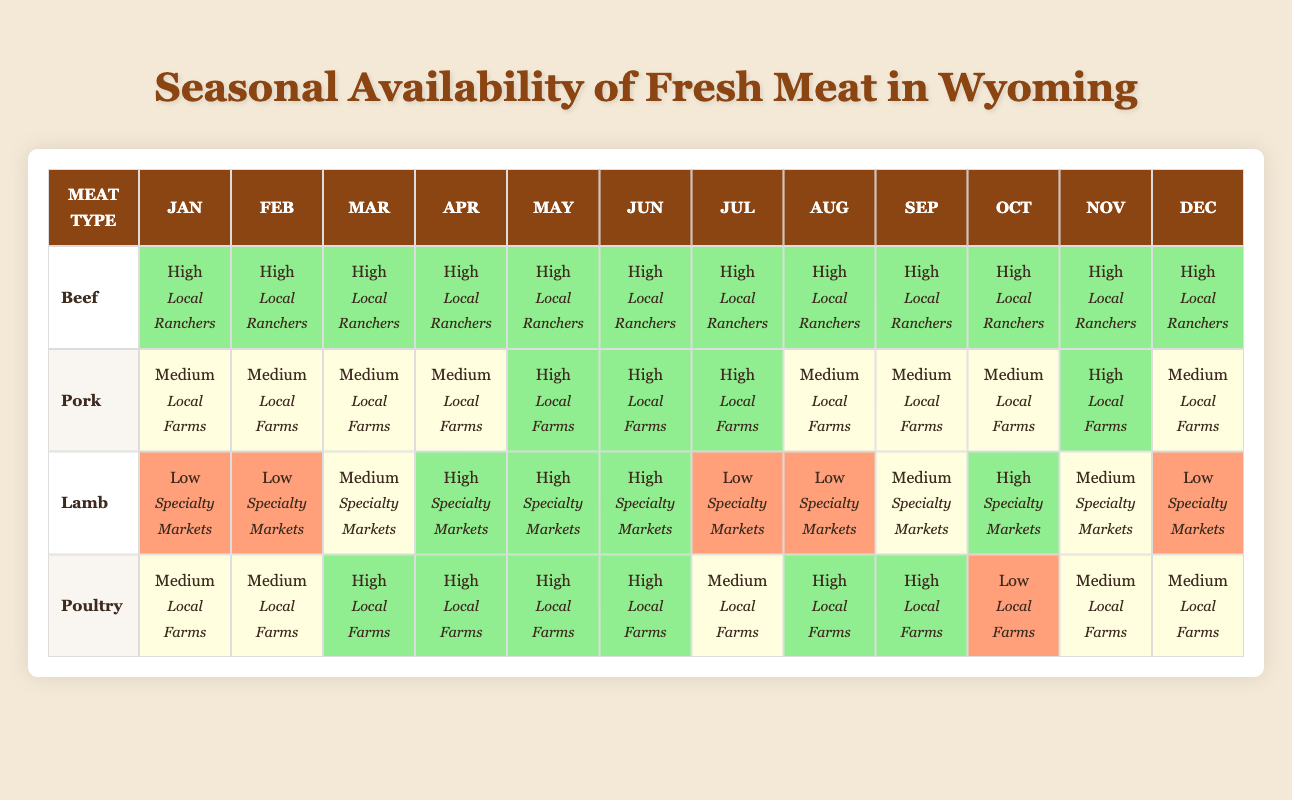What is the availability of beef in January? In January, the table shows "High" availability for beef and specifies the source as "Local Ranchers."
Answer: High During which month does lamb have the highest availability? From the table, lamb shows "High" availability in April, May, and October. The month with the highest availability is therefore April and May.
Answer: April and May Is pork available all year round? The table indicates that pork has "Medium" availability in January, February, March, April, July, August, September, October, December; and "High" availability in May, June, and November. Therefore, it is available all year.
Answer: Yes Which type of meat has the lowest availability in July? The table shows that lamb has "Low" availability in July, while other meats have at least "Medium" availability.
Answer: Lamb In which month is poultry the least available? The table displays "Low" availability for poultry in October, whereas other months have "Medium" or "High" availability.
Answer: October What is the average availability of lamb over the year? Summing the availability ratings (Low = 1, Medium = 2, High = 3) for lamb gives: (1+1+2+3+3+3+1+1+2+3+2+1) = 23. There are 12 months, so the average is 23/12 = about 1.92, which rounds to 2 (Medium).
Answer: Medium What is the trend in beef availability from January to June? The table shows that beef maintains "High" availability from January through June without any fluctuations.
Answer: No trend; consistent high availability In how many months does pork have "High" availability? Reviewing the table, pork shows "High" availability in May, June, and November only. Thus, it is available for a total of three months at this level.
Answer: Three months Which meat transitions from Medium to High availability in March? The table illustrates that poultry transitions from "Medium" availability in January and February to "High" availability in March.
Answer: Poultry Which two meats have low availability in July and August? By looking at the table, lamb has "Low" availability in both July and August, while pork is "Medium" in both months. Thus, only lamb meets the criteria.
Answer: Lamb 